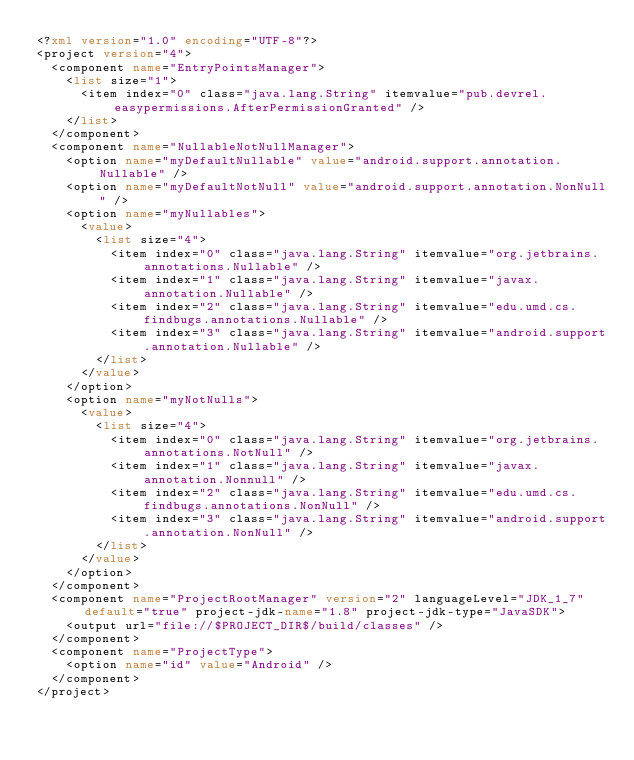<code> <loc_0><loc_0><loc_500><loc_500><_XML_><?xml version="1.0" encoding="UTF-8"?>
<project version="4">
  <component name="EntryPointsManager">
    <list size="1">
      <item index="0" class="java.lang.String" itemvalue="pub.devrel.easypermissions.AfterPermissionGranted" />
    </list>
  </component>
  <component name="NullableNotNullManager">
    <option name="myDefaultNullable" value="android.support.annotation.Nullable" />
    <option name="myDefaultNotNull" value="android.support.annotation.NonNull" />
    <option name="myNullables">
      <value>
        <list size="4">
          <item index="0" class="java.lang.String" itemvalue="org.jetbrains.annotations.Nullable" />
          <item index="1" class="java.lang.String" itemvalue="javax.annotation.Nullable" />
          <item index="2" class="java.lang.String" itemvalue="edu.umd.cs.findbugs.annotations.Nullable" />
          <item index="3" class="java.lang.String" itemvalue="android.support.annotation.Nullable" />
        </list>
      </value>
    </option>
    <option name="myNotNulls">
      <value>
        <list size="4">
          <item index="0" class="java.lang.String" itemvalue="org.jetbrains.annotations.NotNull" />
          <item index="1" class="java.lang.String" itemvalue="javax.annotation.Nonnull" />
          <item index="2" class="java.lang.String" itemvalue="edu.umd.cs.findbugs.annotations.NonNull" />
          <item index="3" class="java.lang.String" itemvalue="android.support.annotation.NonNull" />
        </list>
      </value>
    </option>
  </component>
  <component name="ProjectRootManager" version="2" languageLevel="JDK_1_7" default="true" project-jdk-name="1.8" project-jdk-type="JavaSDK">
    <output url="file://$PROJECT_DIR$/build/classes" />
  </component>
  <component name="ProjectType">
    <option name="id" value="Android" />
  </component>
</project></code> 